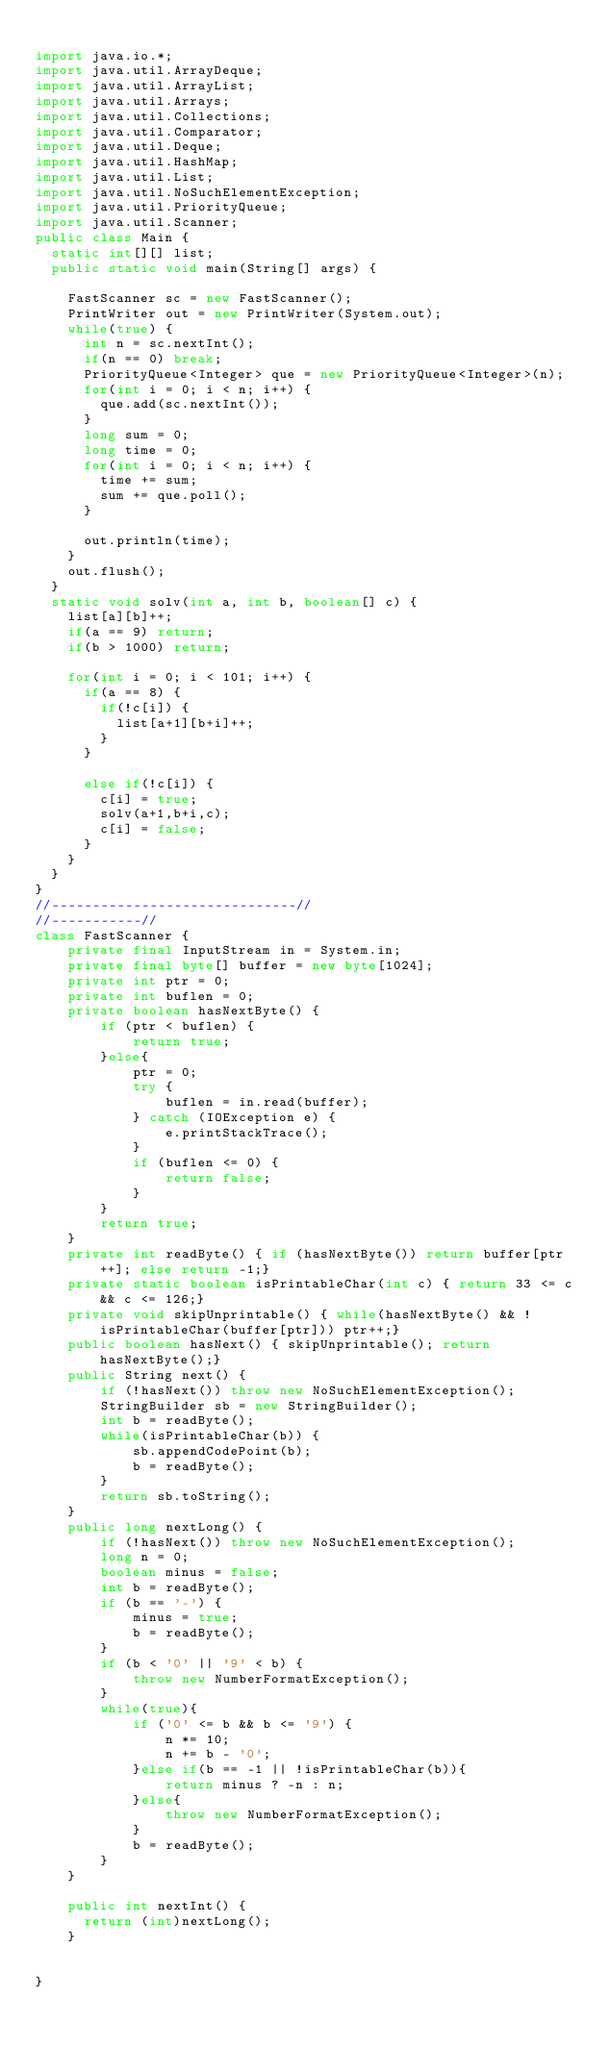<code> <loc_0><loc_0><loc_500><loc_500><_Java_>
import java.io.*;
import java.util.ArrayDeque;
import java.util.ArrayList;
import java.util.Arrays;
import java.util.Collections;
import java.util.Comparator;
import java.util.Deque;
import java.util.HashMap;
import java.util.List;
import java.util.NoSuchElementException;
import java.util.PriorityQueue;
import java.util.Scanner;
public class Main {
	static int[][] list;
	public static void main(String[] args) {
		
		FastScanner sc = new FastScanner();
		PrintWriter out = new PrintWriter(System.out);
		while(true) {
			int n = sc.nextInt();
			if(n == 0) break;
			PriorityQueue<Integer> que = new PriorityQueue<Integer>(n);
			for(int i = 0; i < n; i++) {
				que.add(sc.nextInt());
			}
			long sum = 0;
			long time = 0;
			for(int i = 0; i < n; i++) {
				time += sum;
				sum += que.poll();
			}
			
			out.println(time);
		}
		out.flush();
	}
	static void solv(int a, int b, boolean[] c) {
		list[a][b]++;
		if(a == 9) return;
		if(b > 1000) return;
		
		for(int i = 0; i < 101; i++) {
			if(a == 8) {
				if(!c[i]) {
					list[a+1][b+i]++;
				}
			}
			
			else if(!c[i]) {
				c[i] = true;
				solv(a+1,b+i,c);
				c[i] = false;
			}
		}
	}
}
//------------------------------//
//-----------//
class FastScanner {
    private final InputStream in = System.in;
    private final byte[] buffer = new byte[1024];
    private int ptr = 0;
    private int buflen = 0;
    private boolean hasNextByte() {
        if (ptr < buflen) {
            return true;
        }else{
            ptr = 0;
            try {
                buflen = in.read(buffer);
            } catch (IOException e) {
                e.printStackTrace();
            }
            if (buflen <= 0) {
                return false;
            }
        }
        return true;
    }
    private int readByte() { if (hasNextByte()) return buffer[ptr++]; else return -1;}
    private static boolean isPrintableChar(int c) { return 33 <= c && c <= 126;}
    private void skipUnprintable() { while(hasNextByte() && !isPrintableChar(buffer[ptr])) ptr++;}
    public boolean hasNext() { skipUnprintable(); return hasNextByte();}
    public String next() {
        if (!hasNext()) throw new NoSuchElementException();
        StringBuilder sb = new StringBuilder();
        int b = readByte();
        while(isPrintableChar(b)) {
            sb.appendCodePoint(b);
            b = readByte();
        }
        return sb.toString();
    }
    public long nextLong() {
        if (!hasNext()) throw new NoSuchElementException();
        long n = 0;
        boolean minus = false;
        int b = readByte();
        if (b == '-') {
            minus = true;
            b = readByte();
        }
        if (b < '0' || '9' < b) {
            throw new NumberFormatException();
        }
        while(true){
            if ('0' <= b && b <= '9') {
                n *= 10;
                n += b - '0';
            }else if(b == -1 || !isPrintableChar(b)){
                return minus ? -n : n;
            }else{
                throw new NumberFormatException();
            }
            b = readByte();
        }
    }
    
    public int nextInt() {
    	return (int)nextLong();
    }
    

}</code> 